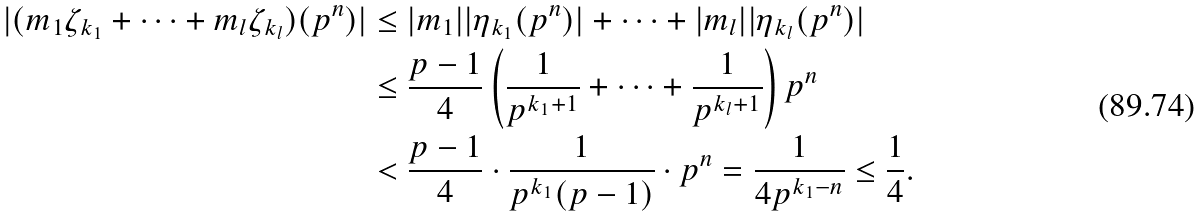<formula> <loc_0><loc_0><loc_500><loc_500>| ( m _ { 1 } \zeta _ { k _ { 1 } } + \cdots + m _ { l } \zeta _ { k _ { l } } ) ( p ^ { n } ) | & \leq | m _ { 1 } | | \eta _ { k _ { 1 } } ( p ^ { n } ) | + \cdots + | m _ { l } | | \eta _ { k _ { l } } ( p ^ { n } ) | \\ & \leq \frac { p - 1 } 4 \left ( \frac { 1 } { p ^ { k _ { 1 } + 1 } } + \cdots + \frac { 1 } { p ^ { k _ { l } + 1 } } \right ) p ^ { n } \\ & < \frac { p - 1 } 4 \cdot \frac { 1 } { p ^ { k _ { 1 } } ( p - 1 ) } \cdot p ^ { n } = \frac { 1 } { 4 p ^ { k _ { 1 } - n } } \leq \frac { 1 } { 4 } .</formula> 